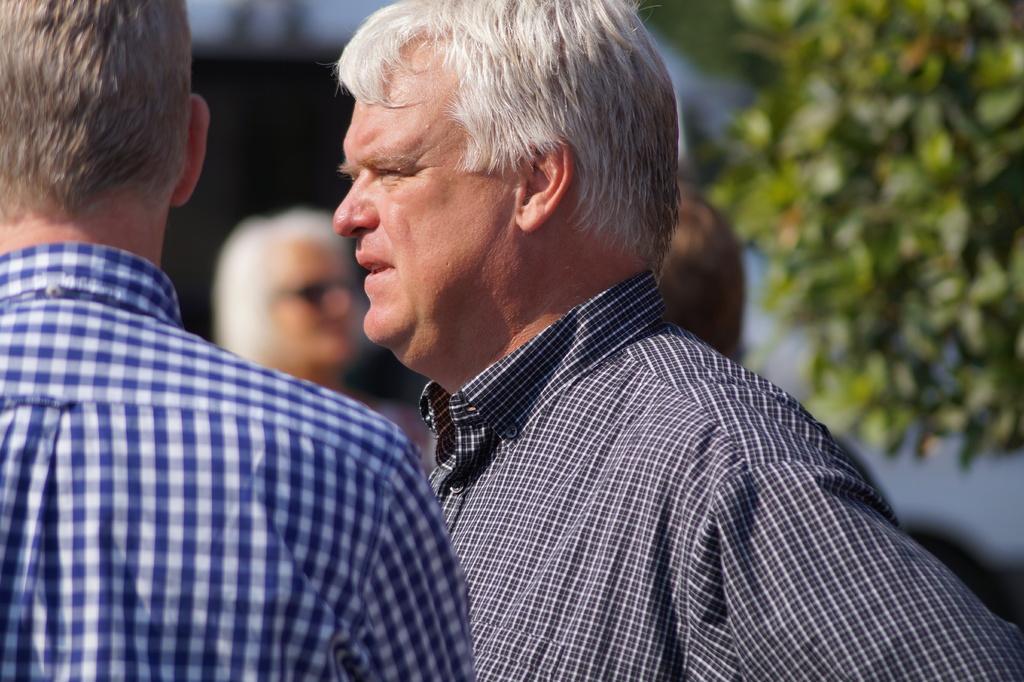Could you give a brief overview of what you see in this image? In this image I can see two persons. In front the person is Wearing blue and white shirt, and the person at right wearing black and white shirt, at back I can see few other persons standing, trees in green color. 